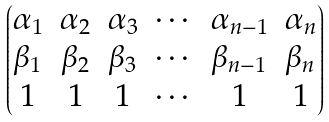<formula> <loc_0><loc_0><loc_500><loc_500>\begin{pmatrix} \alpha _ { 1 } & \alpha _ { 2 } & \alpha _ { 3 } & \cdots & \alpha _ { n - 1 } & \alpha _ { n } \\ \beta _ { 1 } & \beta _ { 2 } & \beta _ { 3 } & \cdots & \beta _ { n - 1 } & \beta _ { n } \\ 1 & 1 & 1 & \cdots & 1 & 1 \end{pmatrix}</formula> 